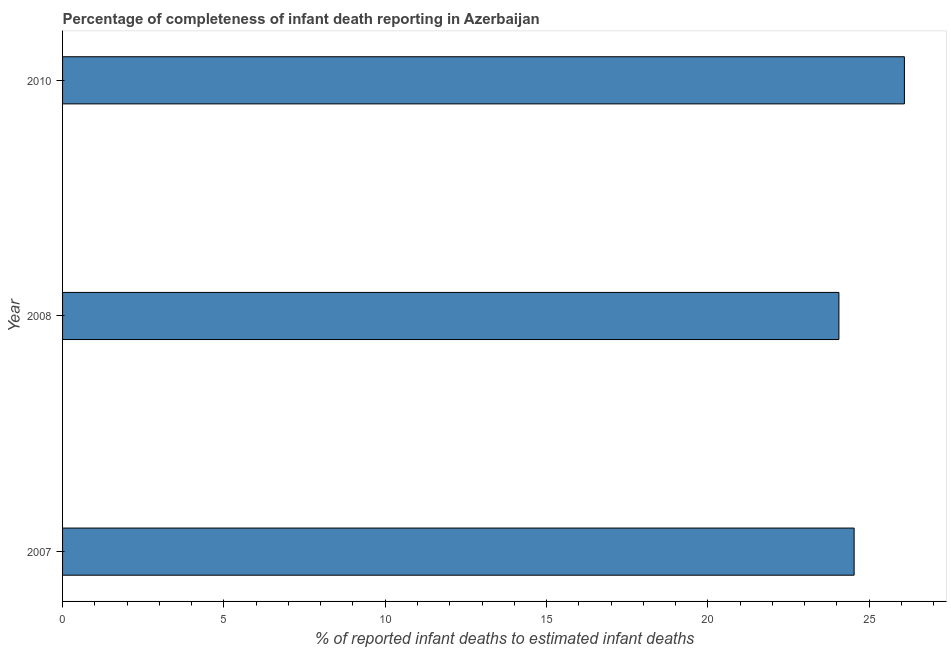Does the graph contain any zero values?
Ensure brevity in your answer.  No. What is the title of the graph?
Give a very brief answer. Percentage of completeness of infant death reporting in Azerbaijan. What is the label or title of the X-axis?
Offer a terse response. % of reported infant deaths to estimated infant deaths. What is the label or title of the Y-axis?
Provide a short and direct response. Year. What is the completeness of infant death reporting in 2007?
Provide a short and direct response. 24.53. Across all years, what is the maximum completeness of infant death reporting?
Offer a terse response. 26.09. Across all years, what is the minimum completeness of infant death reporting?
Your answer should be very brief. 24.06. In which year was the completeness of infant death reporting minimum?
Offer a very short reply. 2008. What is the sum of the completeness of infant death reporting?
Provide a short and direct response. 74.68. What is the difference between the completeness of infant death reporting in 2008 and 2010?
Make the answer very short. -2.03. What is the average completeness of infant death reporting per year?
Offer a very short reply. 24.89. What is the median completeness of infant death reporting?
Your answer should be compact. 24.53. In how many years, is the completeness of infant death reporting greater than 16 %?
Offer a terse response. 3. What is the ratio of the completeness of infant death reporting in 2007 to that in 2010?
Your answer should be very brief. 0.94. What is the difference between the highest and the second highest completeness of infant death reporting?
Your answer should be compact. 1.56. What is the difference between the highest and the lowest completeness of infant death reporting?
Make the answer very short. 2.03. In how many years, is the completeness of infant death reporting greater than the average completeness of infant death reporting taken over all years?
Offer a terse response. 1. Are all the bars in the graph horizontal?
Give a very brief answer. Yes. What is the % of reported infant deaths to estimated infant deaths of 2007?
Provide a short and direct response. 24.53. What is the % of reported infant deaths to estimated infant deaths of 2008?
Offer a very short reply. 24.06. What is the % of reported infant deaths to estimated infant deaths of 2010?
Keep it short and to the point. 26.09. What is the difference between the % of reported infant deaths to estimated infant deaths in 2007 and 2008?
Your response must be concise. 0.47. What is the difference between the % of reported infant deaths to estimated infant deaths in 2007 and 2010?
Your answer should be very brief. -1.56. What is the difference between the % of reported infant deaths to estimated infant deaths in 2008 and 2010?
Provide a succinct answer. -2.03. What is the ratio of the % of reported infant deaths to estimated infant deaths in 2007 to that in 2010?
Offer a terse response. 0.94. What is the ratio of the % of reported infant deaths to estimated infant deaths in 2008 to that in 2010?
Keep it short and to the point. 0.92. 